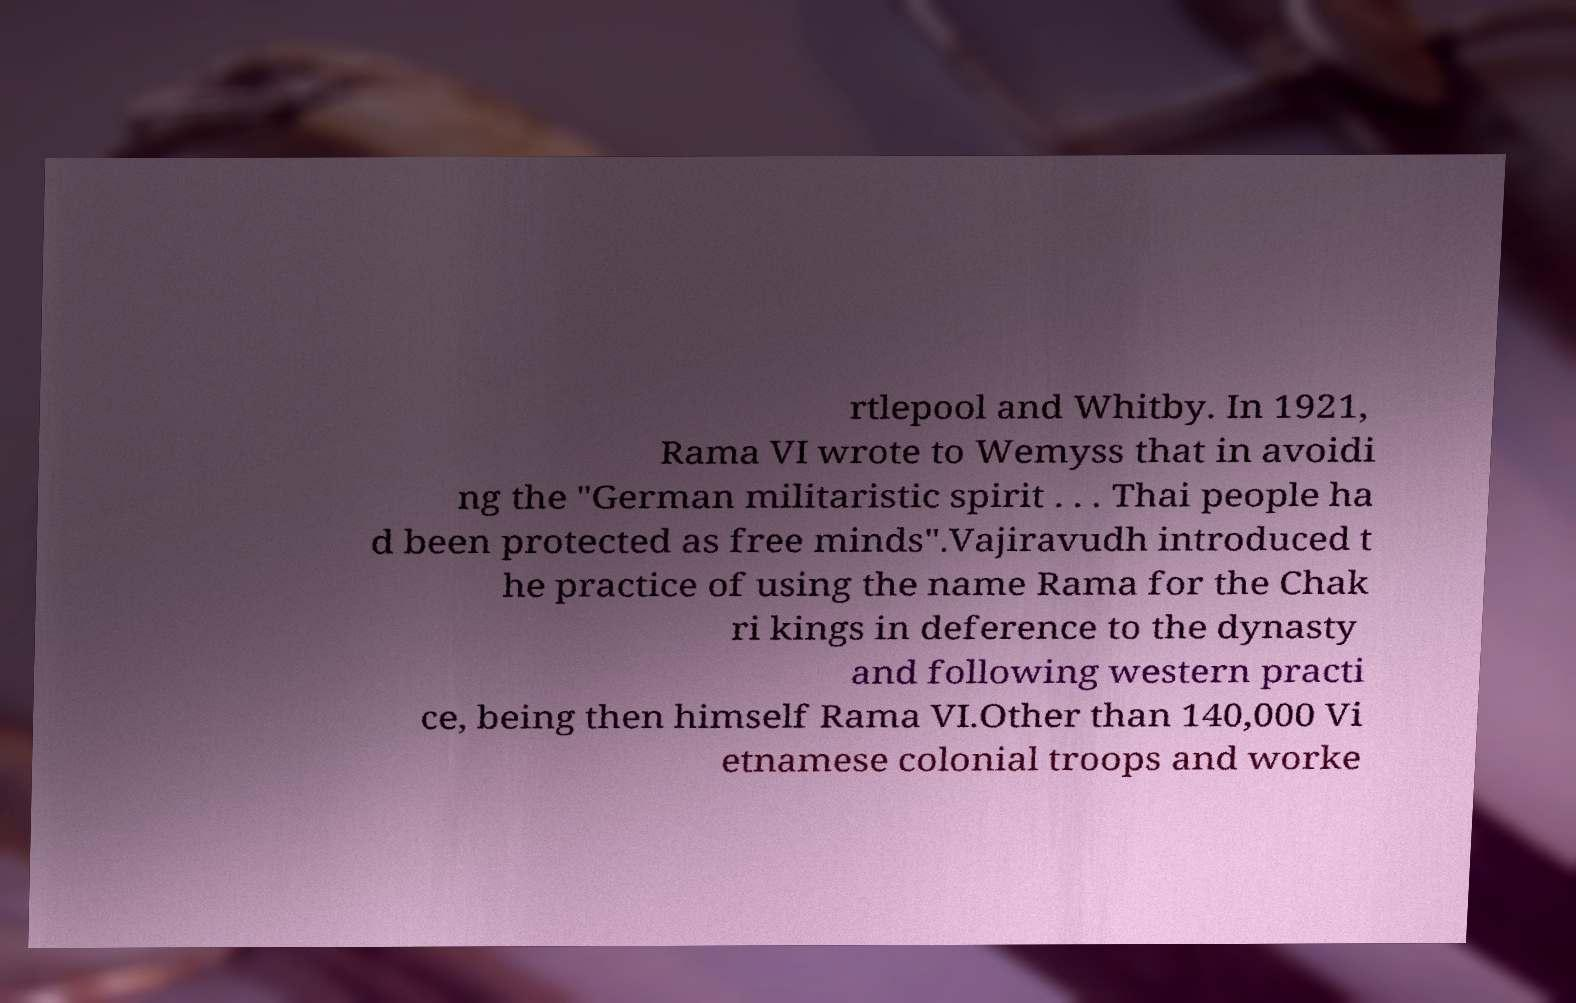Could you assist in decoding the text presented in this image and type it out clearly? rtlepool and Whitby. In 1921, Rama VI wrote to Wemyss that in avoidi ng the "German militaristic spirit . . . Thai people ha d been protected as free minds".Vajiravudh introduced t he practice of using the name Rama for the Chak ri kings in deference to the dynasty and following western practi ce, being then himself Rama VI.Other than 140,000 Vi etnamese colonial troops and worke 